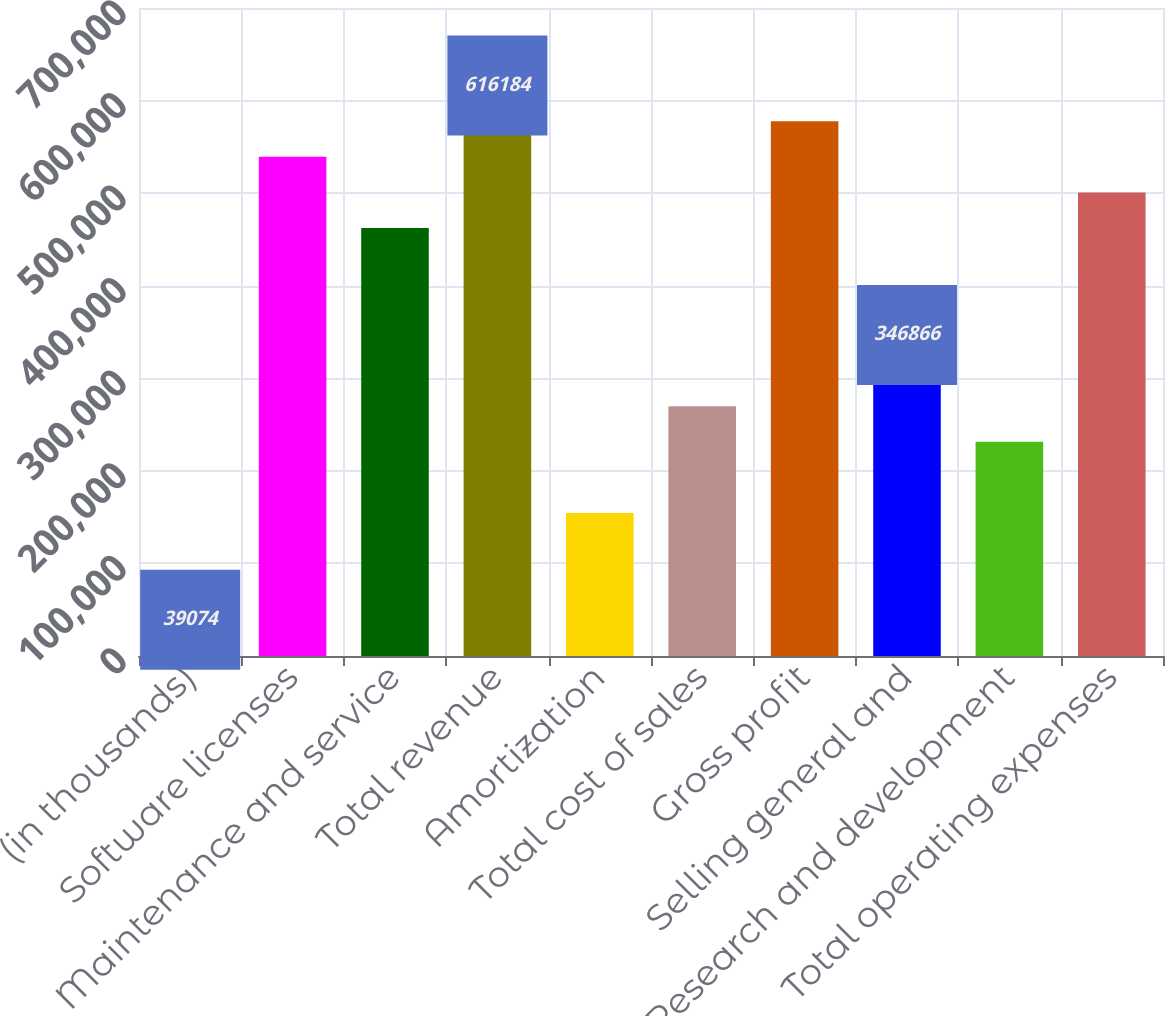Convert chart to OTSL. <chart><loc_0><loc_0><loc_500><loc_500><bar_chart><fcel>(in thousands)<fcel>Software licenses<fcel>Maintenance and service<fcel>Total revenue<fcel>Amortization<fcel>Total cost of sales<fcel>Gross profit<fcel>Selling general and<fcel>Research and development<fcel>Total operating expenses<nl><fcel>39074<fcel>539236<fcel>462288<fcel>616184<fcel>154496<fcel>269918<fcel>577710<fcel>346866<fcel>231444<fcel>500762<nl></chart> 